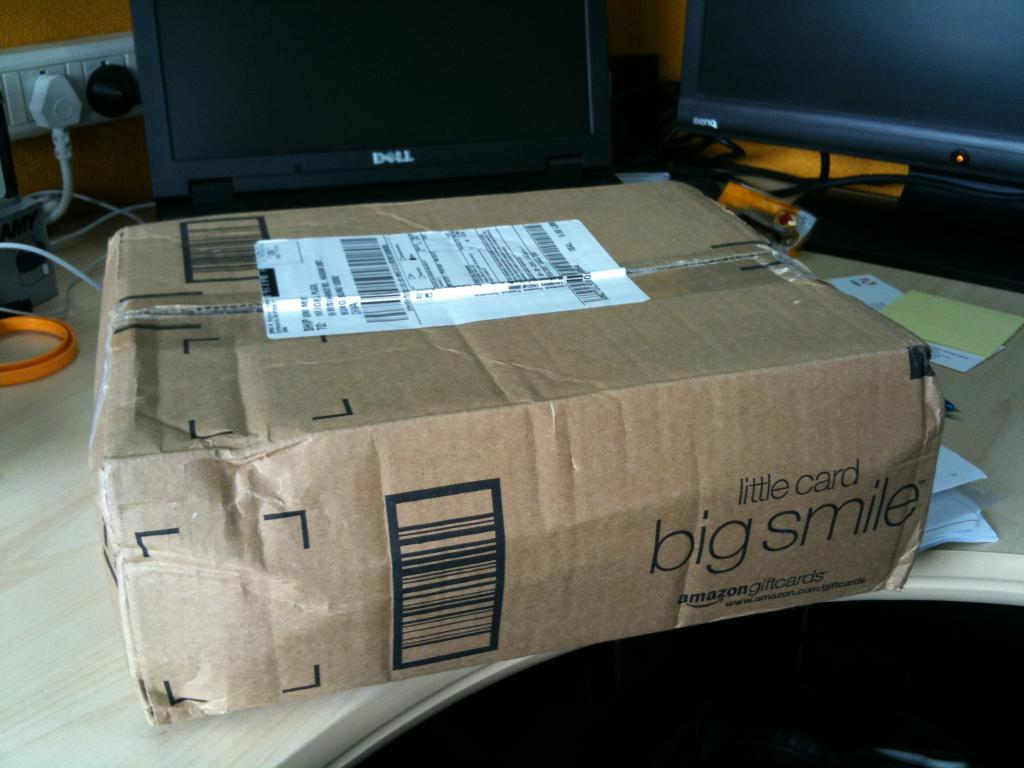<image>
Share a concise interpretation of the image provided. A cardboard box that says little card, big smile. 